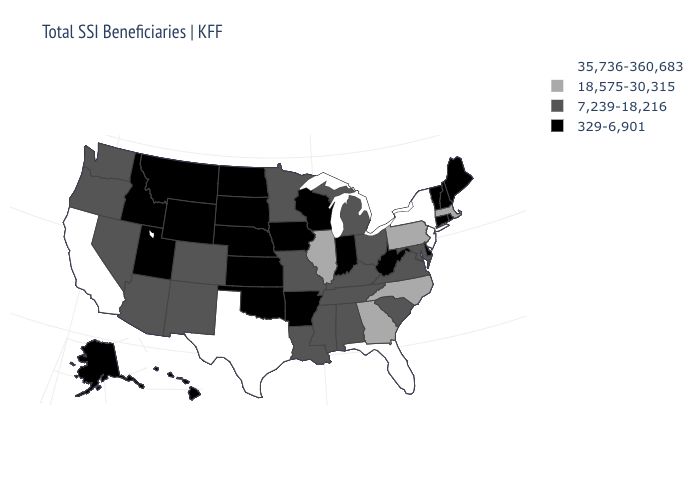Name the states that have a value in the range 329-6,901?
Concise answer only. Alaska, Arkansas, Connecticut, Delaware, Hawaii, Idaho, Indiana, Iowa, Kansas, Maine, Montana, Nebraska, New Hampshire, North Dakota, Oklahoma, Rhode Island, South Dakota, Utah, Vermont, West Virginia, Wisconsin, Wyoming. Name the states that have a value in the range 18,575-30,315?
Write a very short answer. Georgia, Illinois, Massachusetts, North Carolina, Pennsylvania. Does Hawaii have the same value as Kentucky?
Be succinct. No. Name the states that have a value in the range 18,575-30,315?
Keep it brief. Georgia, Illinois, Massachusetts, North Carolina, Pennsylvania. What is the lowest value in states that border Virginia?
Write a very short answer. 329-6,901. Name the states that have a value in the range 35,736-360,683?
Short answer required. California, Florida, New Jersey, New York, Texas. Name the states that have a value in the range 18,575-30,315?
Concise answer only. Georgia, Illinois, Massachusetts, North Carolina, Pennsylvania. Which states have the lowest value in the Northeast?
Keep it brief. Connecticut, Maine, New Hampshire, Rhode Island, Vermont. What is the value of Mississippi?
Write a very short answer. 7,239-18,216. What is the value of Minnesota?
Write a very short answer. 7,239-18,216. Which states hav the highest value in the West?
Keep it brief. California. Among the states that border South Carolina , which have the lowest value?
Be succinct. Georgia, North Carolina. Does Kansas have a lower value than Nevada?
Answer briefly. Yes. What is the highest value in the USA?
Be succinct. 35,736-360,683. Name the states that have a value in the range 18,575-30,315?
Short answer required. Georgia, Illinois, Massachusetts, North Carolina, Pennsylvania. 